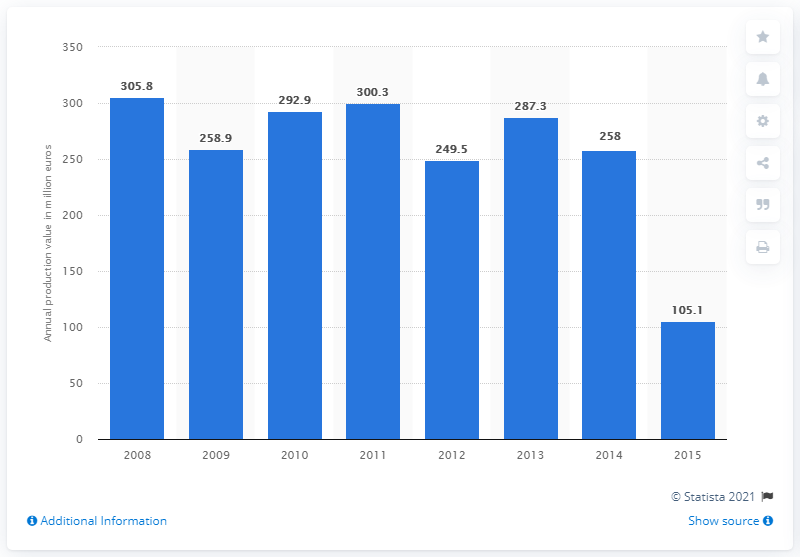Draw attention to some important aspects in this diagram. The production value of the soap and detergents manufacturing industry in Sweden in 2015 was 105.1 million euros. 